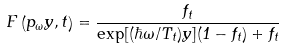<formula> <loc_0><loc_0><loc_500><loc_500>F \left ( p _ { \omega } y , t \right ) = \frac { f _ { t } } { \exp [ ( \hbar { \omega } / T _ { t } ) y ] ( 1 - f _ { t } ) + f _ { t } }</formula> 